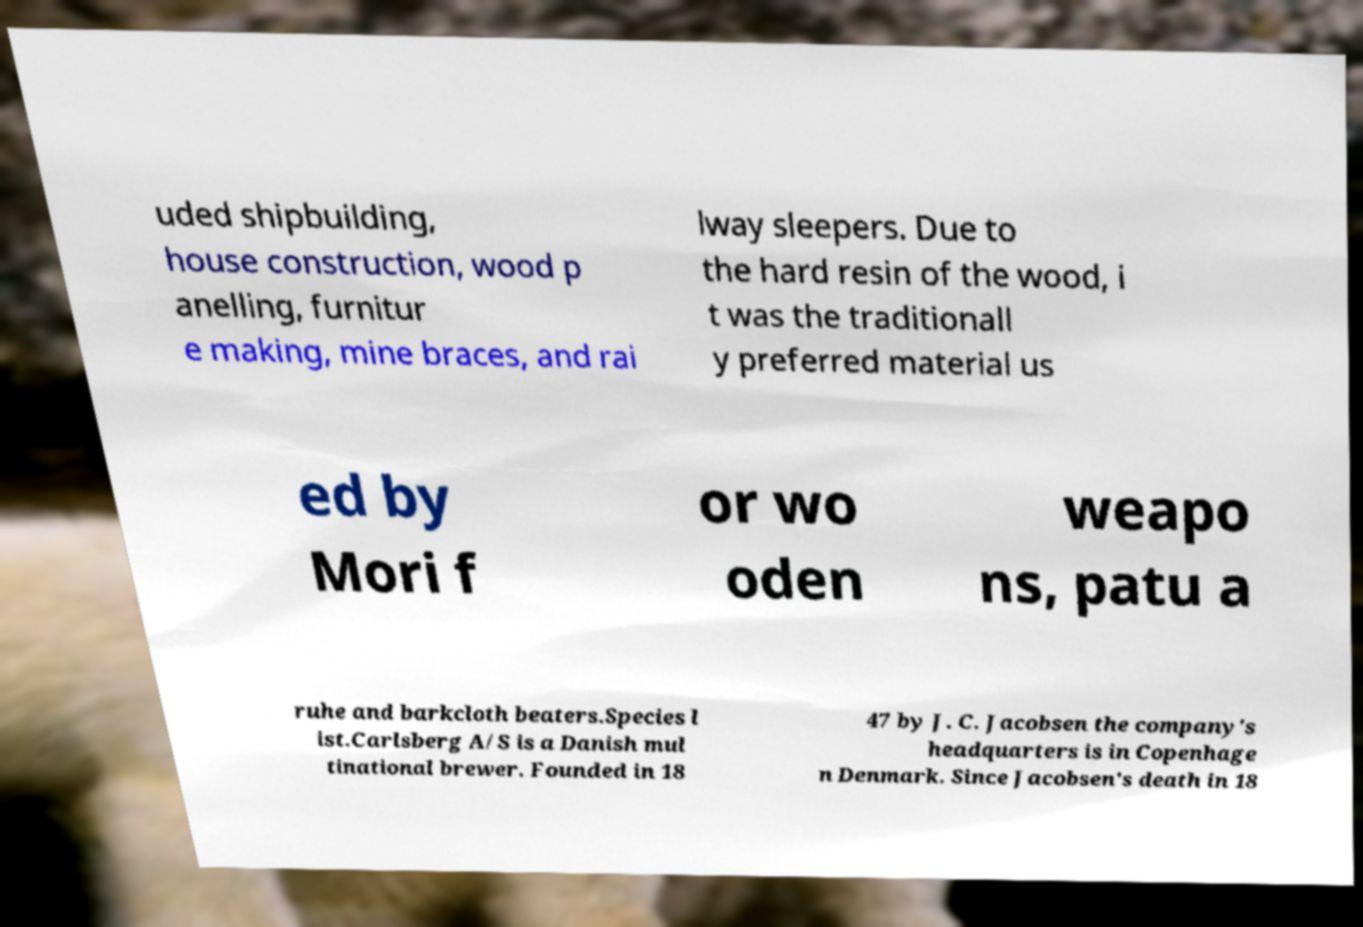Please identify and transcribe the text found in this image. uded shipbuilding, house construction, wood p anelling, furnitur e making, mine braces, and rai lway sleepers. Due to the hard resin of the wood, i t was the traditionall y preferred material us ed by Mori f or wo oden weapo ns, patu a ruhe and barkcloth beaters.Species l ist.Carlsberg A/S is a Danish mul tinational brewer. Founded in 18 47 by J. C. Jacobsen the company's headquarters is in Copenhage n Denmark. Since Jacobsen's death in 18 